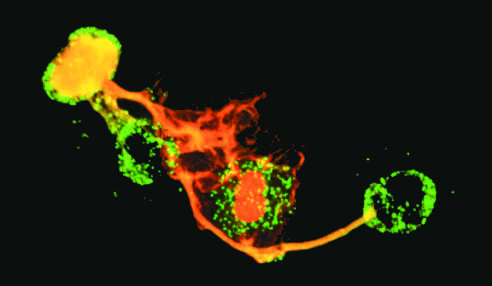what have lost their nuclei?
Answer the question using a single word or phrase. Neutrophils 